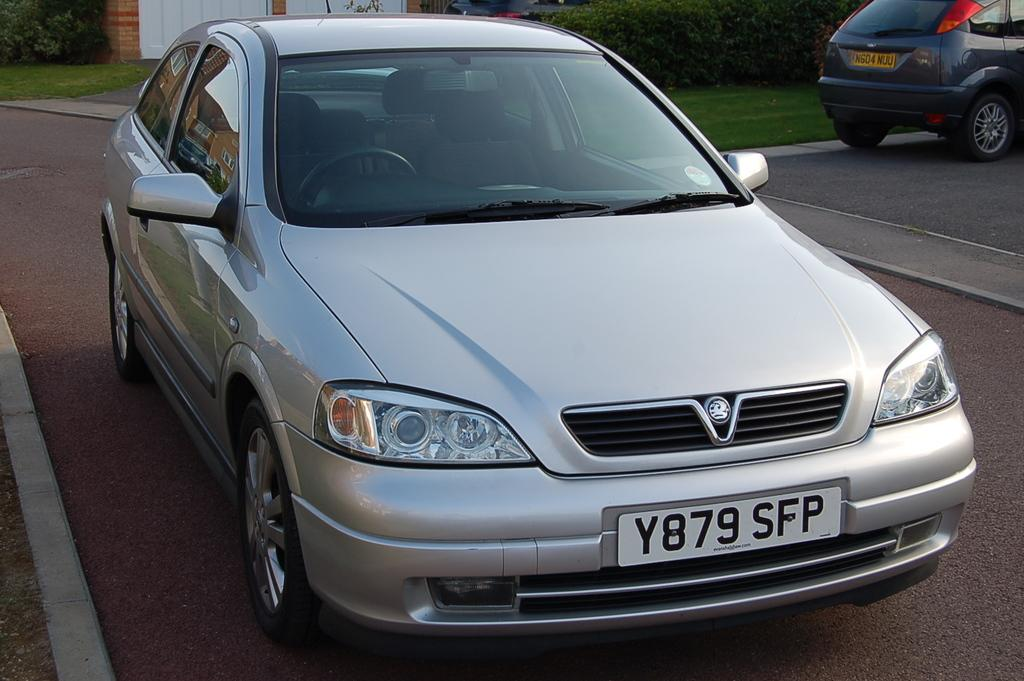What can be seen on the road in the image? There are cars on the road in the image. What type of natural environment is visible in the background? There is grass and plants visible in the background of the image. Can any cars be seen in the background of the image? Yes, there is at least one car in the background of the image. What type of structure is present in the background of the image? There is a wall in the background of the image. What type of peace symbol can be seen on the cars in the image? There is no peace symbol visible on the cars in the image. How does the muscle of the car affect its performance in the image? There is no mention of a muscle or its performance in the image; it only shows cars on the road and the surrounding environment. 